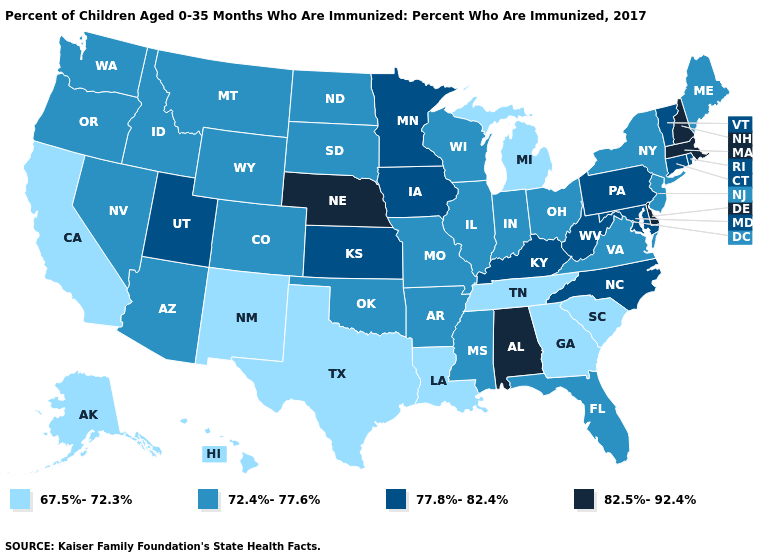Name the states that have a value in the range 67.5%-72.3%?
Short answer required. Alaska, California, Georgia, Hawaii, Louisiana, Michigan, New Mexico, South Carolina, Tennessee, Texas. Does New Hampshire have a higher value than Arkansas?
Give a very brief answer. Yes. What is the value of West Virginia?
Quick response, please. 77.8%-82.4%. Does Wyoming have the lowest value in the West?
Answer briefly. No. What is the highest value in states that border Michigan?
Answer briefly. 72.4%-77.6%. Name the states that have a value in the range 72.4%-77.6%?
Give a very brief answer. Arizona, Arkansas, Colorado, Florida, Idaho, Illinois, Indiana, Maine, Mississippi, Missouri, Montana, Nevada, New Jersey, New York, North Dakota, Ohio, Oklahoma, Oregon, South Dakota, Virginia, Washington, Wisconsin, Wyoming. Does Alabama have the highest value in the USA?
Be succinct. Yes. Among the states that border North Carolina , does Virginia have the highest value?
Quick response, please. Yes. Among the states that border Washington , which have the lowest value?
Give a very brief answer. Idaho, Oregon. What is the highest value in states that border Rhode Island?
Quick response, please. 82.5%-92.4%. Does Ohio have a higher value than Oregon?
Give a very brief answer. No. Among the states that border Utah , which have the highest value?
Be succinct. Arizona, Colorado, Idaho, Nevada, Wyoming. Among the states that border New Jersey , does New York have the lowest value?
Write a very short answer. Yes. Does Alabama have the highest value in the USA?
Keep it brief. Yes. Does New Jersey have the highest value in the Northeast?
Answer briefly. No. 